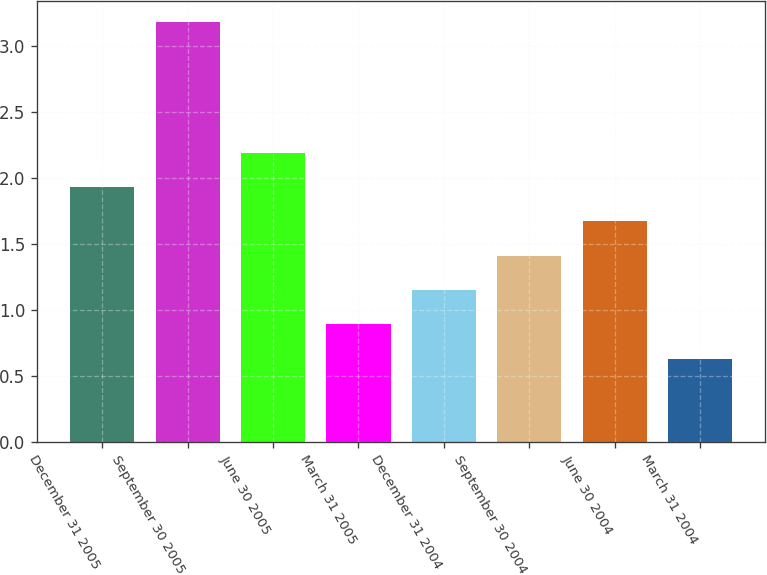Convert chart. <chart><loc_0><loc_0><loc_500><loc_500><bar_chart><fcel>December 31 2005<fcel>September 30 2005<fcel>June 30 2005<fcel>March 31 2005<fcel>December 31 2004<fcel>September 30 2004<fcel>June 30 2004<fcel>March 31 2004<nl><fcel>1.93<fcel>3.18<fcel>2.19<fcel>0.89<fcel>1.15<fcel>1.41<fcel>1.67<fcel>0.63<nl></chart> 